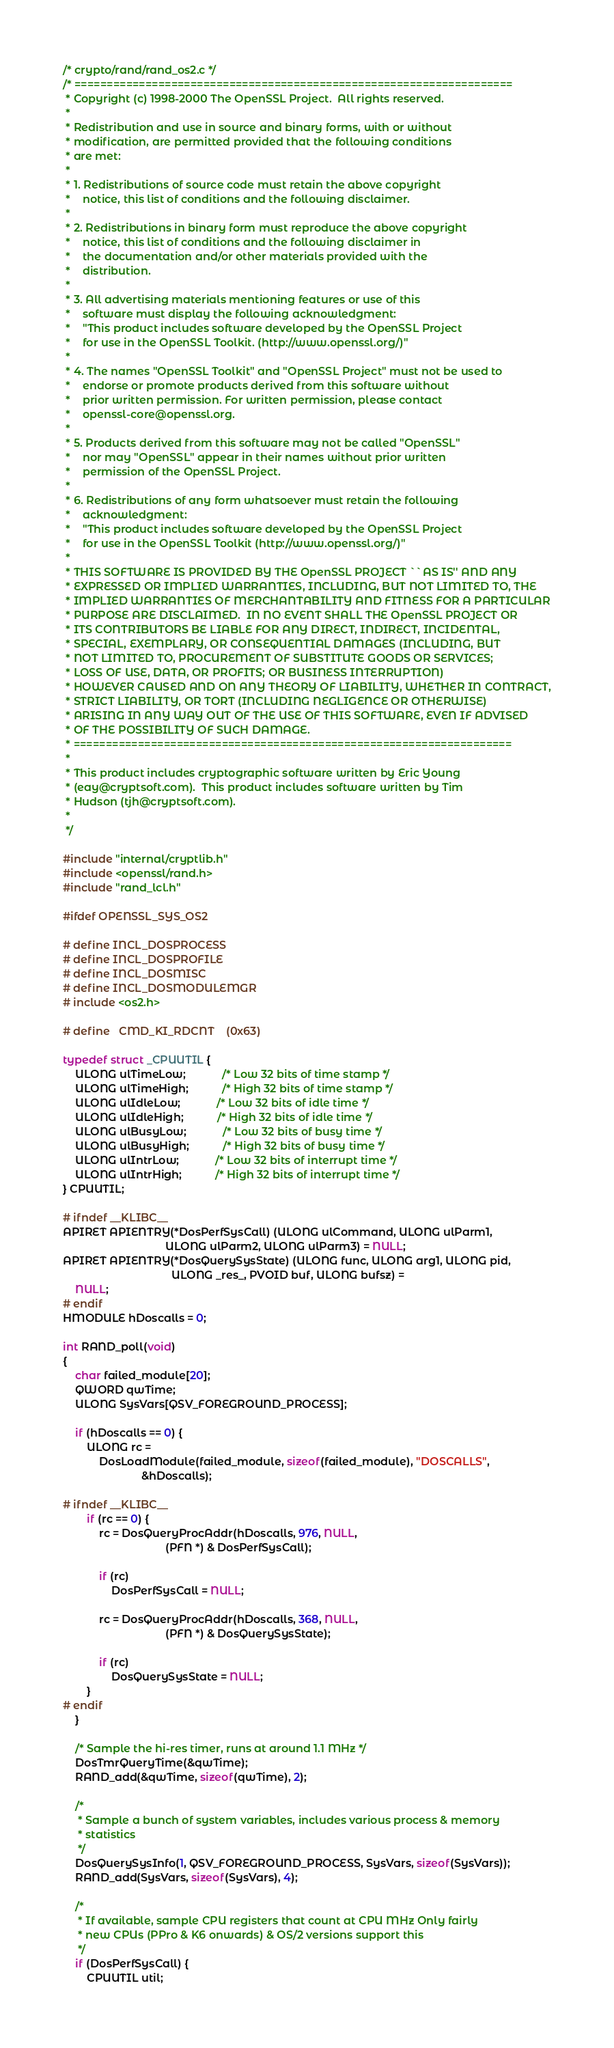Convert code to text. <code><loc_0><loc_0><loc_500><loc_500><_C_>/* crypto/rand/rand_os2.c */
/* ====================================================================
 * Copyright (c) 1998-2000 The OpenSSL Project.  All rights reserved.
 *
 * Redistribution and use in source and binary forms, with or without
 * modification, are permitted provided that the following conditions
 * are met:
 *
 * 1. Redistributions of source code must retain the above copyright
 *    notice, this list of conditions and the following disclaimer.
 *
 * 2. Redistributions in binary form must reproduce the above copyright
 *    notice, this list of conditions and the following disclaimer in
 *    the documentation and/or other materials provided with the
 *    distribution.
 *
 * 3. All advertising materials mentioning features or use of this
 *    software must display the following acknowledgment:
 *    "This product includes software developed by the OpenSSL Project
 *    for use in the OpenSSL Toolkit. (http://www.openssl.org/)"
 *
 * 4. The names "OpenSSL Toolkit" and "OpenSSL Project" must not be used to
 *    endorse or promote products derived from this software without
 *    prior written permission. For written permission, please contact
 *    openssl-core@openssl.org.
 *
 * 5. Products derived from this software may not be called "OpenSSL"
 *    nor may "OpenSSL" appear in their names without prior written
 *    permission of the OpenSSL Project.
 *
 * 6. Redistributions of any form whatsoever must retain the following
 *    acknowledgment:
 *    "This product includes software developed by the OpenSSL Project
 *    for use in the OpenSSL Toolkit (http://www.openssl.org/)"
 *
 * THIS SOFTWARE IS PROVIDED BY THE OpenSSL PROJECT ``AS IS'' AND ANY
 * EXPRESSED OR IMPLIED WARRANTIES, INCLUDING, BUT NOT LIMITED TO, THE
 * IMPLIED WARRANTIES OF MERCHANTABILITY AND FITNESS FOR A PARTICULAR
 * PURPOSE ARE DISCLAIMED.  IN NO EVENT SHALL THE OpenSSL PROJECT OR
 * ITS CONTRIBUTORS BE LIABLE FOR ANY DIRECT, INDIRECT, INCIDENTAL,
 * SPECIAL, EXEMPLARY, OR CONSEQUENTIAL DAMAGES (INCLUDING, BUT
 * NOT LIMITED TO, PROCUREMENT OF SUBSTITUTE GOODS OR SERVICES;
 * LOSS OF USE, DATA, OR PROFITS; OR BUSINESS INTERRUPTION)
 * HOWEVER CAUSED AND ON ANY THEORY OF LIABILITY, WHETHER IN CONTRACT,
 * STRICT LIABILITY, OR TORT (INCLUDING NEGLIGENCE OR OTHERWISE)
 * ARISING IN ANY WAY OUT OF THE USE OF THIS SOFTWARE, EVEN IF ADVISED
 * OF THE POSSIBILITY OF SUCH DAMAGE.
 * ====================================================================
 *
 * This product includes cryptographic software written by Eric Young
 * (eay@cryptsoft.com).  This product includes software written by Tim
 * Hudson (tjh@cryptsoft.com).
 *
 */

#include "internal/cryptlib.h"
#include <openssl/rand.h>
#include "rand_lcl.h"

#ifdef OPENSSL_SYS_OS2

# define INCL_DOSPROCESS
# define INCL_DOSPROFILE
# define INCL_DOSMISC
# define INCL_DOSMODULEMGR
# include <os2.h>

# define   CMD_KI_RDCNT    (0x63)

typedef struct _CPUUTIL {
    ULONG ulTimeLow;            /* Low 32 bits of time stamp */
    ULONG ulTimeHigh;           /* High 32 bits of time stamp */
    ULONG ulIdleLow;            /* Low 32 bits of idle time */
    ULONG ulIdleHigh;           /* High 32 bits of idle time */
    ULONG ulBusyLow;            /* Low 32 bits of busy time */
    ULONG ulBusyHigh;           /* High 32 bits of busy time */
    ULONG ulIntrLow;            /* Low 32 bits of interrupt time */
    ULONG ulIntrHigh;           /* High 32 bits of interrupt time */
} CPUUTIL;

# ifndef __KLIBC__
APIRET APIENTRY(*DosPerfSysCall) (ULONG ulCommand, ULONG ulParm1,
                                  ULONG ulParm2, ULONG ulParm3) = NULL;
APIRET APIENTRY(*DosQuerySysState) (ULONG func, ULONG arg1, ULONG pid,
                                    ULONG _res_, PVOID buf, ULONG bufsz) =
    NULL;
# endif
HMODULE hDoscalls = 0;

int RAND_poll(void)
{
    char failed_module[20];
    QWORD qwTime;
    ULONG SysVars[QSV_FOREGROUND_PROCESS];

    if (hDoscalls == 0) {
        ULONG rc =
            DosLoadModule(failed_module, sizeof(failed_module), "DOSCALLS",
                          &hDoscalls);

# ifndef __KLIBC__
        if (rc == 0) {
            rc = DosQueryProcAddr(hDoscalls, 976, NULL,
                                  (PFN *) & DosPerfSysCall);

            if (rc)
                DosPerfSysCall = NULL;

            rc = DosQueryProcAddr(hDoscalls, 368, NULL,
                                  (PFN *) & DosQuerySysState);

            if (rc)
                DosQuerySysState = NULL;
        }
# endif
    }

    /* Sample the hi-res timer, runs at around 1.1 MHz */
    DosTmrQueryTime(&qwTime);
    RAND_add(&qwTime, sizeof(qwTime), 2);

    /*
     * Sample a bunch of system variables, includes various process & memory
     * statistics
     */
    DosQuerySysInfo(1, QSV_FOREGROUND_PROCESS, SysVars, sizeof(SysVars));
    RAND_add(SysVars, sizeof(SysVars), 4);

    /*
     * If available, sample CPU registers that count at CPU MHz Only fairly
     * new CPUs (PPro & K6 onwards) & OS/2 versions support this
     */
    if (DosPerfSysCall) {
        CPUUTIL util;
</code> 